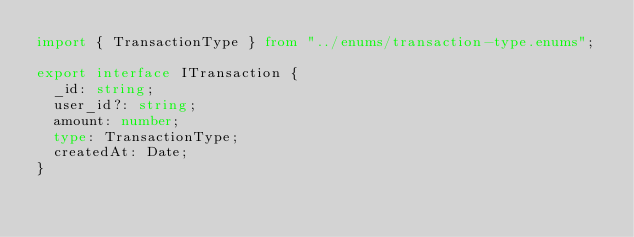<code> <loc_0><loc_0><loc_500><loc_500><_TypeScript_>import { TransactionType } from "../enums/transaction-type.enums";

export interface ITransaction {
  _id: string;
  user_id?: string;
  amount: number;
  type: TransactionType;
  createdAt: Date;
}
</code> 